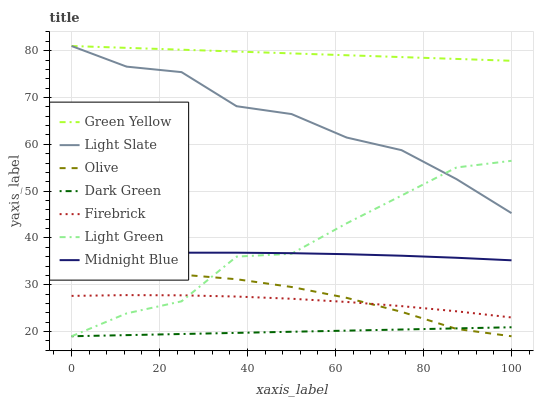Does Dark Green have the minimum area under the curve?
Answer yes or no. Yes. Does Green Yellow have the maximum area under the curve?
Answer yes or no. Yes. Does Light Slate have the minimum area under the curve?
Answer yes or no. No. Does Light Slate have the maximum area under the curve?
Answer yes or no. No. Is Dark Green the smoothest?
Answer yes or no. Yes. Is Light Green the roughest?
Answer yes or no. Yes. Is Light Slate the smoothest?
Answer yes or no. No. Is Light Slate the roughest?
Answer yes or no. No. Does Light Green have the lowest value?
Answer yes or no. Yes. Does Light Slate have the lowest value?
Answer yes or no. No. Does Green Yellow have the highest value?
Answer yes or no. Yes. Does Firebrick have the highest value?
Answer yes or no. No. Is Dark Green less than Light Slate?
Answer yes or no. Yes. Is Green Yellow greater than Dark Green?
Answer yes or no. Yes. Does Light Green intersect Olive?
Answer yes or no. Yes. Is Light Green less than Olive?
Answer yes or no. No. Is Light Green greater than Olive?
Answer yes or no. No. Does Dark Green intersect Light Slate?
Answer yes or no. No. 